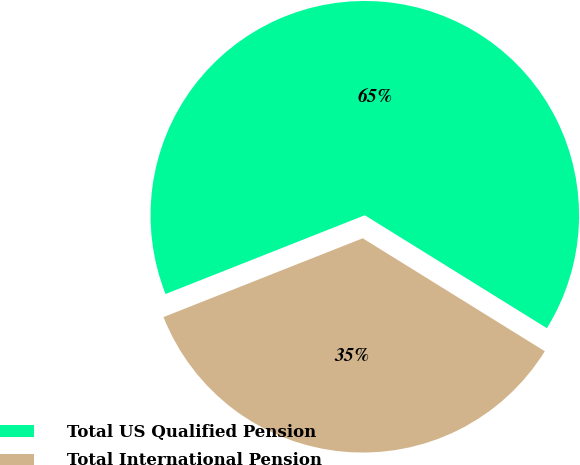Convert chart to OTSL. <chart><loc_0><loc_0><loc_500><loc_500><pie_chart><fcel>Total US Qualified Pension<fcel>Total International Pension<nl><fcel>64.83%<fcel>35.17%<nl></chart> 